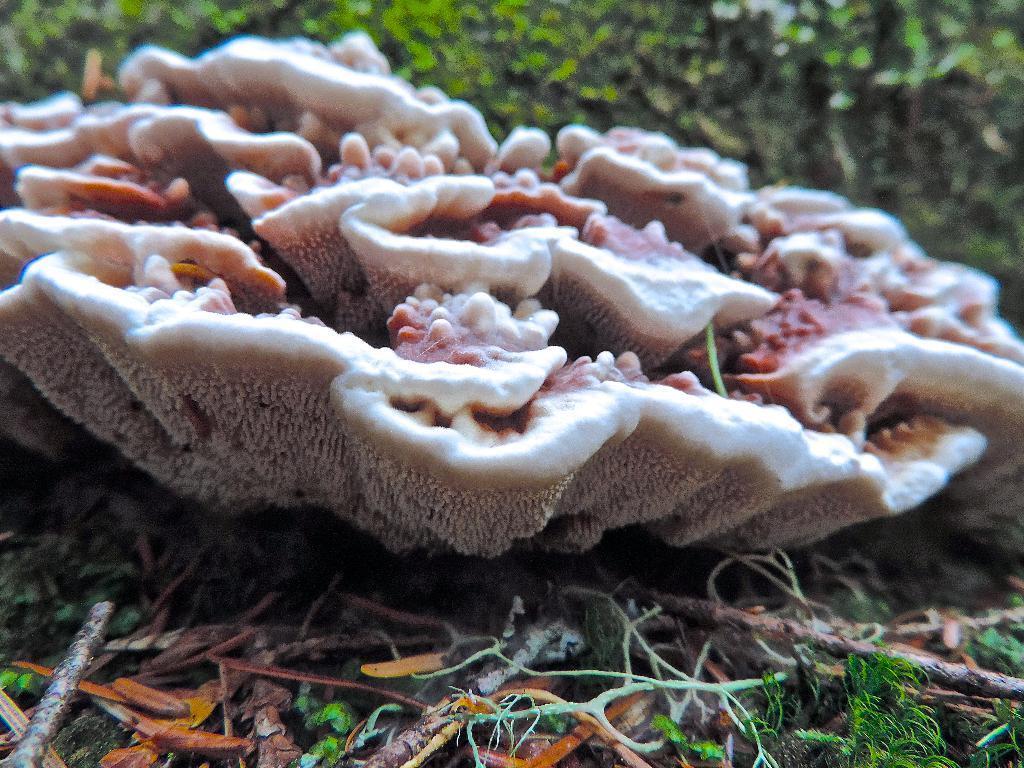In one or two sentences, can you explain what this image depicts? In this image, we can see some mushrooms on the ground. 